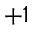<formula> <loc_0><loc_0><loc_500><loc_500>+ 1</formula> 